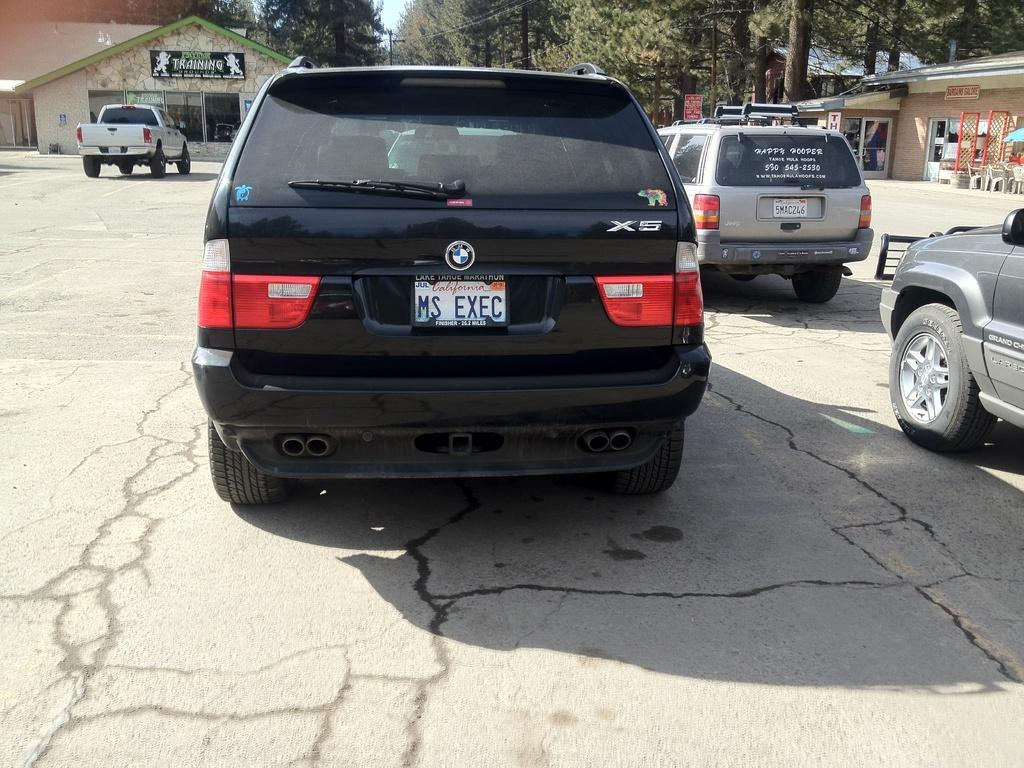<image>
Relay a brief, clear account of the picture shown. A BMW with the personalized plate of MS EXEC is parked in a lot. 